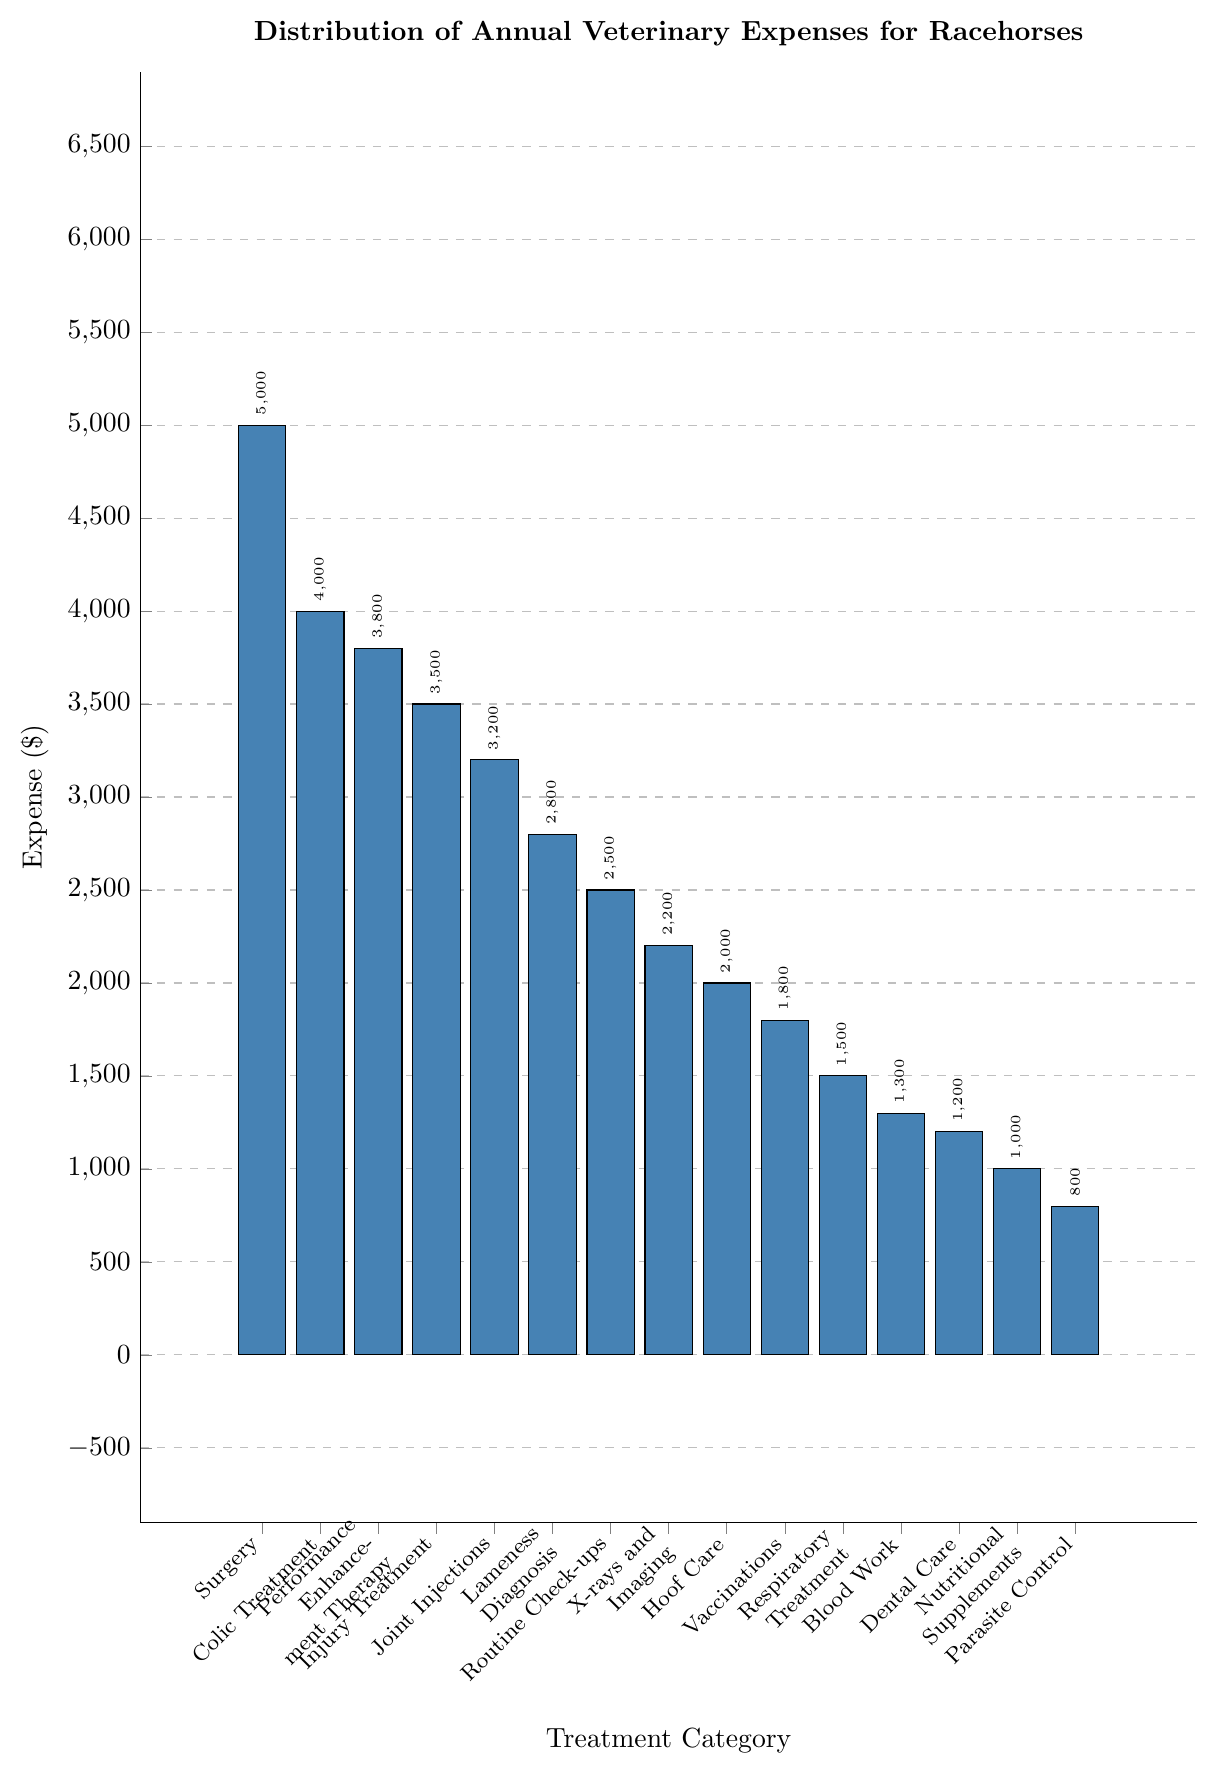What's the most expensive treatment category? Identify the bar that reaches the highest point on the y-axis. The "Surgery" category reaches $5000, which is the highest.
Answer: Surgery How much more is spent on Colic Treatment compared to Vaccinations? Look at the values for Colic Treatment ($4000) and Vaccinations ($1800). Subtract the expense for Vaccinations from the expense for Colic Treatment: $4000 - $1800 = $2200.
Answer: $2200 Which treatment categories have an expense greater than $3000? Identify bars that exceed the $3000 mark on the y-axis. The categories are Surgery ($5000), Colic Treatment ($4000), Performance Enhancement Therapy ($3800), Injury Treatment ($3500), and Joint Injections ($3200).
Answer: Surgery, Colic Treatment, Performance Enhancement Therapy, Injury Treatment, Joint Injections What is the combined expense for Nutritional Supplements and Parasite Control? Check the values for Nutritional Supplements ($1000) and Parasite Control ($800). Add the two expenses together: $1000 + $800 = $1800.
Answer: $1800 Is the expense for Dental Care more or less than for Blood Work, and by how much? Look at the values for Dental Care ($1200) and Blood Work ($1300). The difference is $1300 - $1200 = $100, with Blood Work being more expensive by $100.
Answer: Blood Work by $100 What's the average expense across all treatment categories? Sum all the expenses and divide by the number of categories: 
($5000 + $4000 + $3800 + $3500 + $3200 + $2800 + $2500 + $2200 + $2000 + $1800 + $1500 + $1300 + $1200 + $1000 + $800) / 15 = $33200 / 15 = $2213.33.
Answer: $2213.33 Which treatments cost less than $2000? Identify bars that fall below the $2000 line on the y-axis. The categories are Hoof Care ($2000), Vaccinations ($1800), Respiratory Treatment ($1500), Blood Work ($1300), Dental Care ($1200), Nutritional Supplements ($1000), and Parasite Control ($800).
Answer: Vaccinations, Respiratory Treatment, Blood Work, Dental Care, Nutritional Supplements, Parasite Control How much less expensive is Respiratory Treatment compared to Joint Injections? Compare the values for Respiratory Treatment ($1500) and Joint Injections ($3200). The difference is $3200 - $1500 = $1700.
Answer: $1700 What's the visual difference between the bar for Routine Check-ups and X-rays and Imaging? Observe the height of the bars. Routine Check-ups are at $2500 while X-rays and Imaging are at $2200, showing that the bar for X-rays and Imaging is slightly shorter. The difference is $2500 - $2200 = $300.
Answer: $300 What is the difference between the highest and lowest expenses in the chart? Identify the highest (Surgery at $5000) and lowest (Parasite Control at $800) values. Subtract the lowest from the highest: $5000 - $800 = $4200.
Answer: $4200 